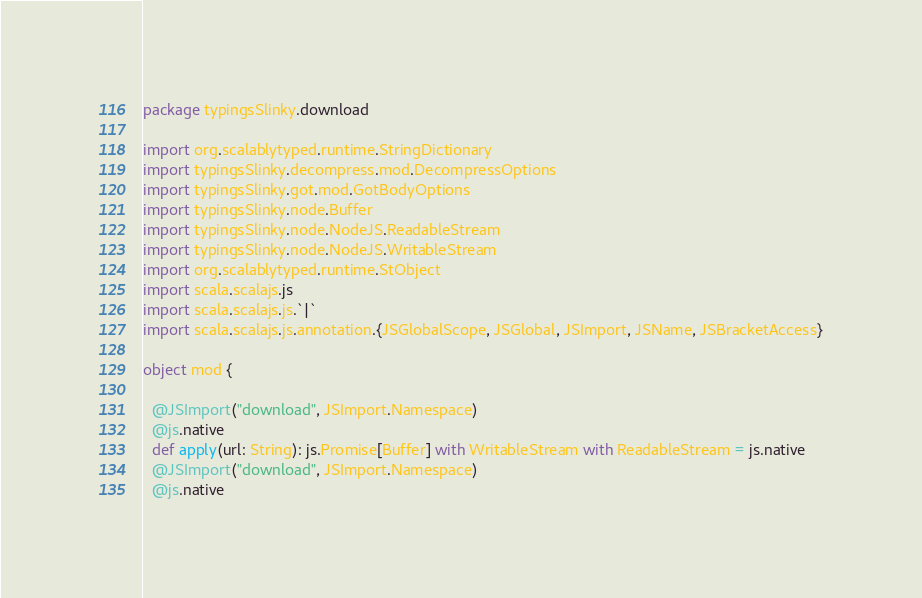Convert code to text. <code><loc_0><loc_0><loc_500><loc_500><_Scala_>package typingsSlinky.download

import org.scalablytyped.runtime.StringDictionary
import typingsSlinky.decompress.mod.DecompressOptions
import typingsSlinky.got.mod.GotBodyOptions
import typingsSlinky.node.Buffer
import typingsSlinky.node.NodeJS.ReadableStream
import typingsSlinky.node.NodeJS.WritableStream
import org.scalablytyped.runtime.StObject
import scala.scalajs.js
import scala.scalajs.js.`|`
import scala.scalajs.js.annotation.{JSGlobalScope, JSGlobal, JSImport, JSName, JSBracketAccess}

object mod {
  
  @JSImport("download", JSImport.Namespace)
  @js.native
  def apply(url: String): js.Promise[Buffer] with WritableStream with ReadableStream = js.native
  @JSImport("download", JSImport.Namespace)
  @js.native</code> 